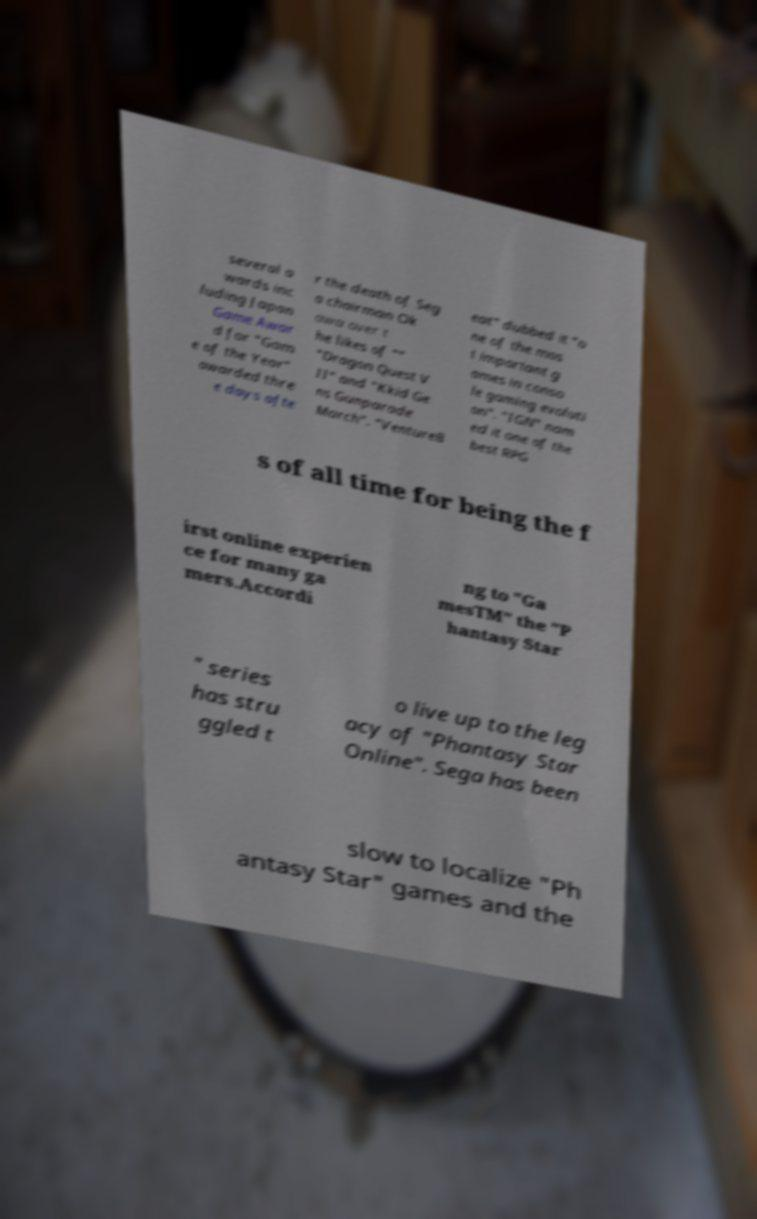Could you assist in decoding the text presented in this image and type it out clearly? several a wards inc luding Japan Game Awar d for "Gam e of the Year" awarded thre e days afte r the death of Seg a chairman Ok awa over t he likes of "" "Dragon Quest V II" and "Kkid Ge ns Gunparade March". "VentureB eat" dubbed it "o ne of the mos t important g ames in conso le gaming evoluti on". "IGN" nam ed it one of the best RPG s of all time for being the f irst online experien ce for many ga mers.Accordi ng to "Ga mesTM" the "P hantasy Star " series has stru ggled t o live up to the leg acy of "Phantasy Star Online". Sega has been slow to localize "Ph antasy Star" games and the 